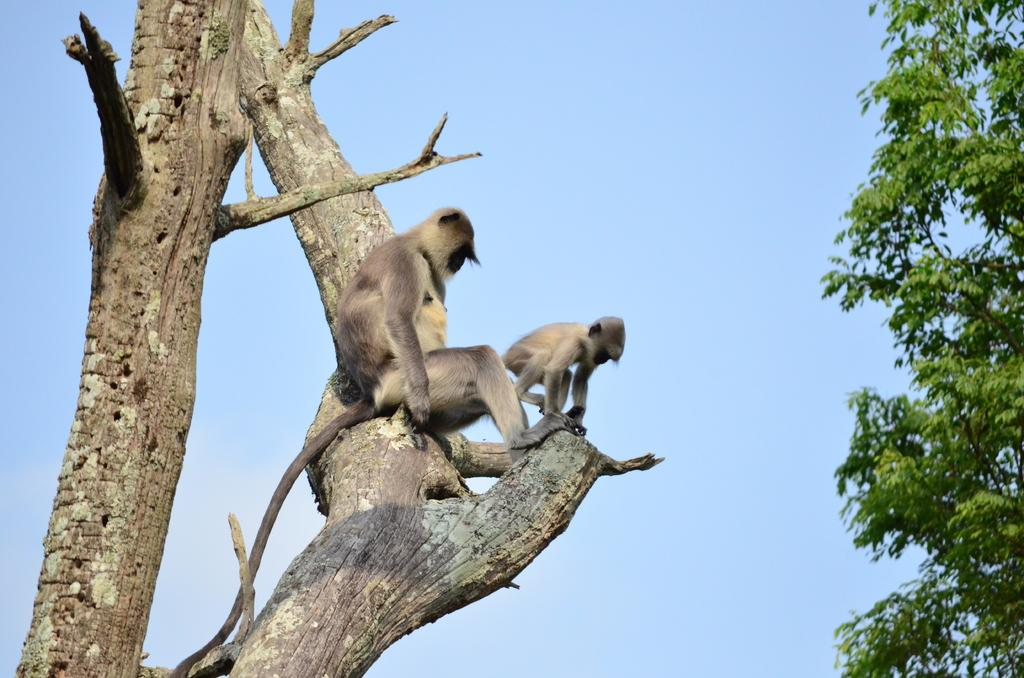How many monkeys are in the image? There are 2 monkeys in the image. What are the monkeys doing in the image? The monkeys are sitting on a branch. What is the branch surrounded by? The branch is surrounded by green leaves. What color is the sky in the image? The sky is blue in the image. What language are the monkeys speaking in the image? Monkeys do not speak human languages, so it is not possible to determine what language they might be speaking in the image. 